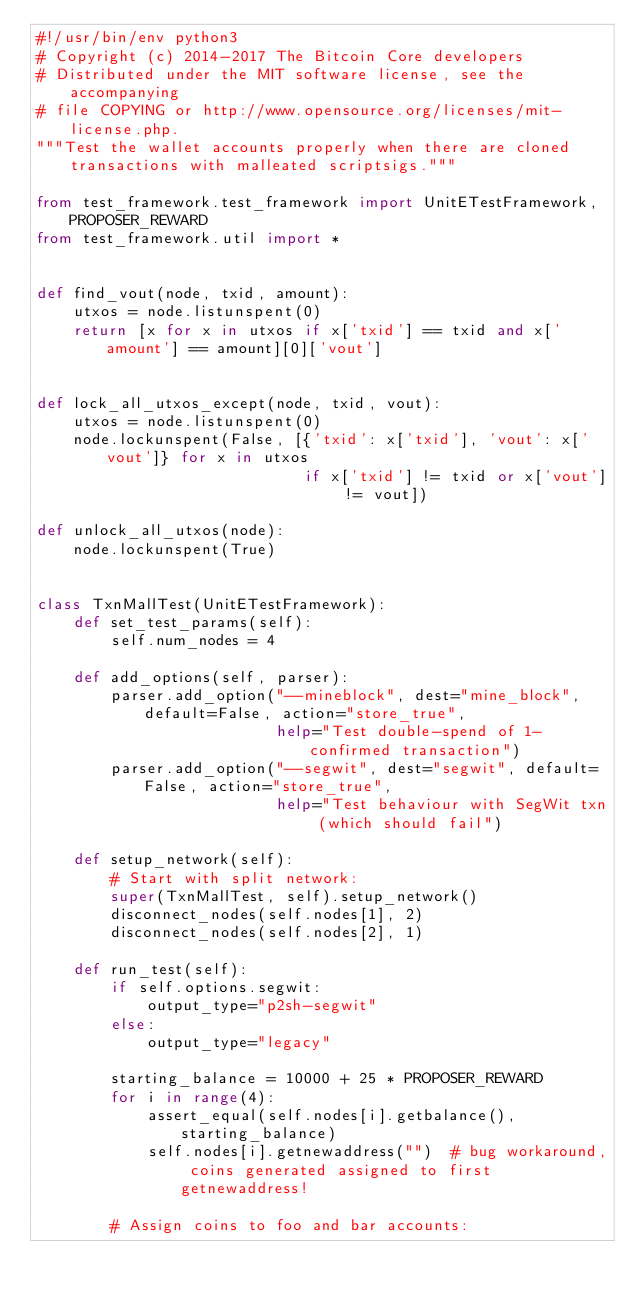Convert code to text. <code><loc_0><loc_0><loc_500><loc_500><_Python_>#!/usr/bin/env python3
# Copyright (c) 2014-2017 The Bitcoin Core developers
# Distributed under the MIT software license, see the accompanying
# file COPYING or http://www.opensource.org/licenses/mit-license.php.
"""Test the wallet accounts properly when there are cloned transactions with malleated scriptsigs."""

from test_framework.test_framework import UnitETestFramework, PROPOSER_REWARD
from test_framework.util import *


def find_vout(node, txid, amount):
    utxos = node.listunspent(0)
    return [x for x in utxos if x['txid'] == txid and x['amount'] == amount][0]['vout']


def lock_all_utxos_except(node, txid, vout):
    utxos = node.listunspent(0)
    node.lockunspent(False, [{'txid': x['txid'], 'vout': x['vout']} for x in utxos
                             if x['txid'] != txid or x['vout'] != vout])

def unlock_all_utxos(node):
    node.lockunspent(True)


class TxnMallTest(UnitETestFramework):
    def set_test_params(self):
        self.num_nodes = 4

    def add_options(self, parser):
        parser.add_option("--mineblock", dest="mine_block", default=False, action="store_true",
                          help="Test double-spend of 1-confirmed transaction")
        parser.add_option("--segwit", dest="segwit", default=False, action="store_true",
                          help="Test behaviour with SegWit txn (which should fail")

    def setup_network(self):
        # Start with split network:
        super(TxnMallTest, self).setup_network()
        disconnect_nodes(self.nodes[1], 2)
        disconnect_nodes(self.nodes[2], 1)

    def run_test(self):
        if self.options.segwit:
            output_type="p2sh-segwit"
        else:
            output_type="legacy"

        starting_balance = 10000 + 25 * PROPOSER_REWARD
        for i in range(4):
            assert_equal(self.nodes[i].getbalance(), starting_balance)
            self.nodes[i].getnewaddress("")  # bug workaround, coins generated assigned to first getnewaddress!

        # Assign coins to foo and bar accounts:</code> 